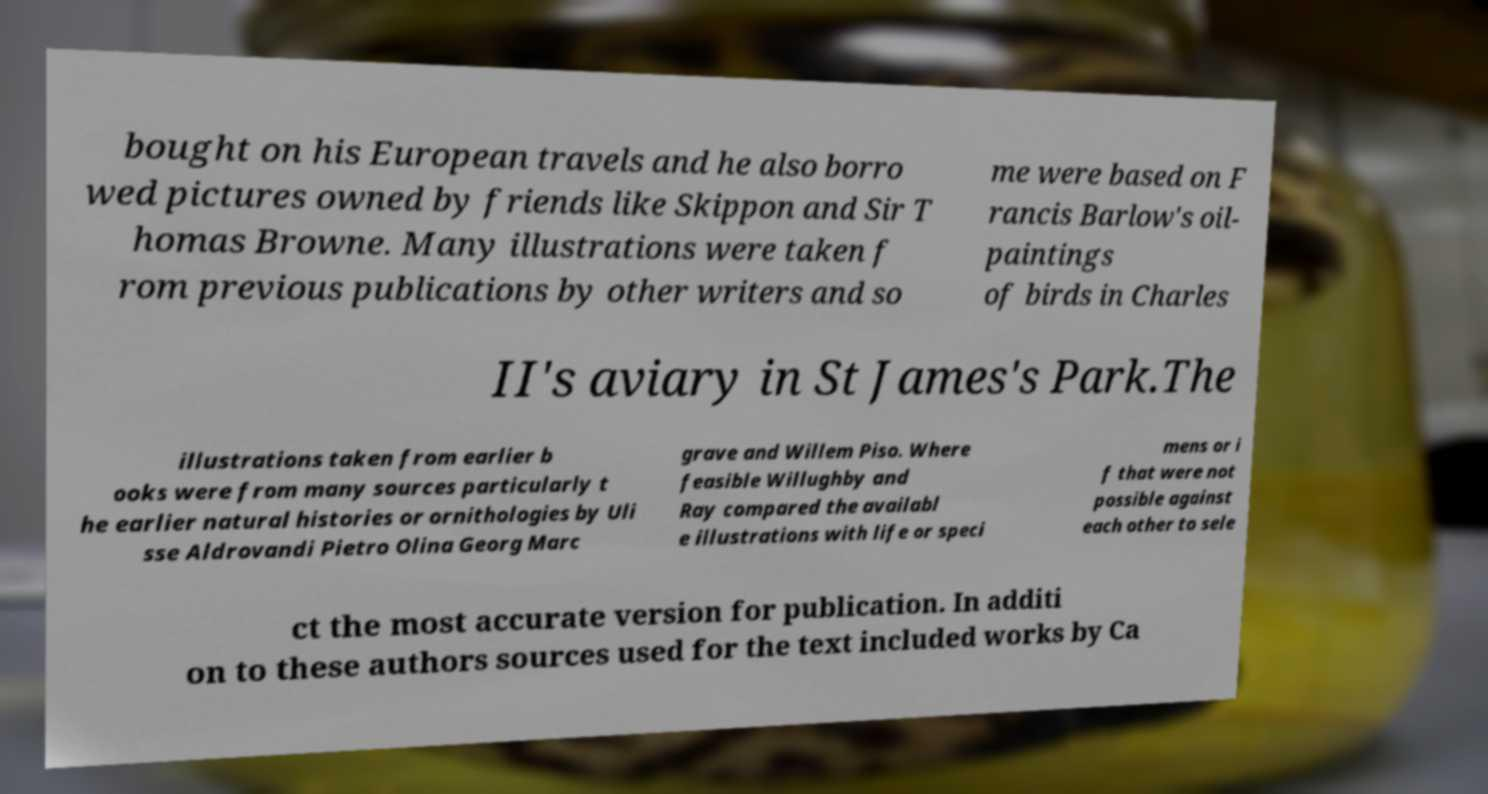Please read and relay the text visible in this image. What does it say? bought on his European travels and he also borro wed pictures owned by friends like Skippon and Sir T homas Browne. Many illustrations were taken f rom previous publications by other writers and so me were based on F rancis Barlow's oil- paintings of birds in Charles II's aviary in St James's Park.The illustrations taken from earlier b ooks were from many sources particularly t he earlier natural histories or ornithologies by Uli sse Aldrovandi Pietro Olina Georg Marc grave and Willem Piso. Where feasible Willughby and Ray compared the availabl e illustrations with life or speci mens or i f that were not possible against each other to sele ct the most accurate version for publication. In additi on to these authors sources used for the text included works by Ca 